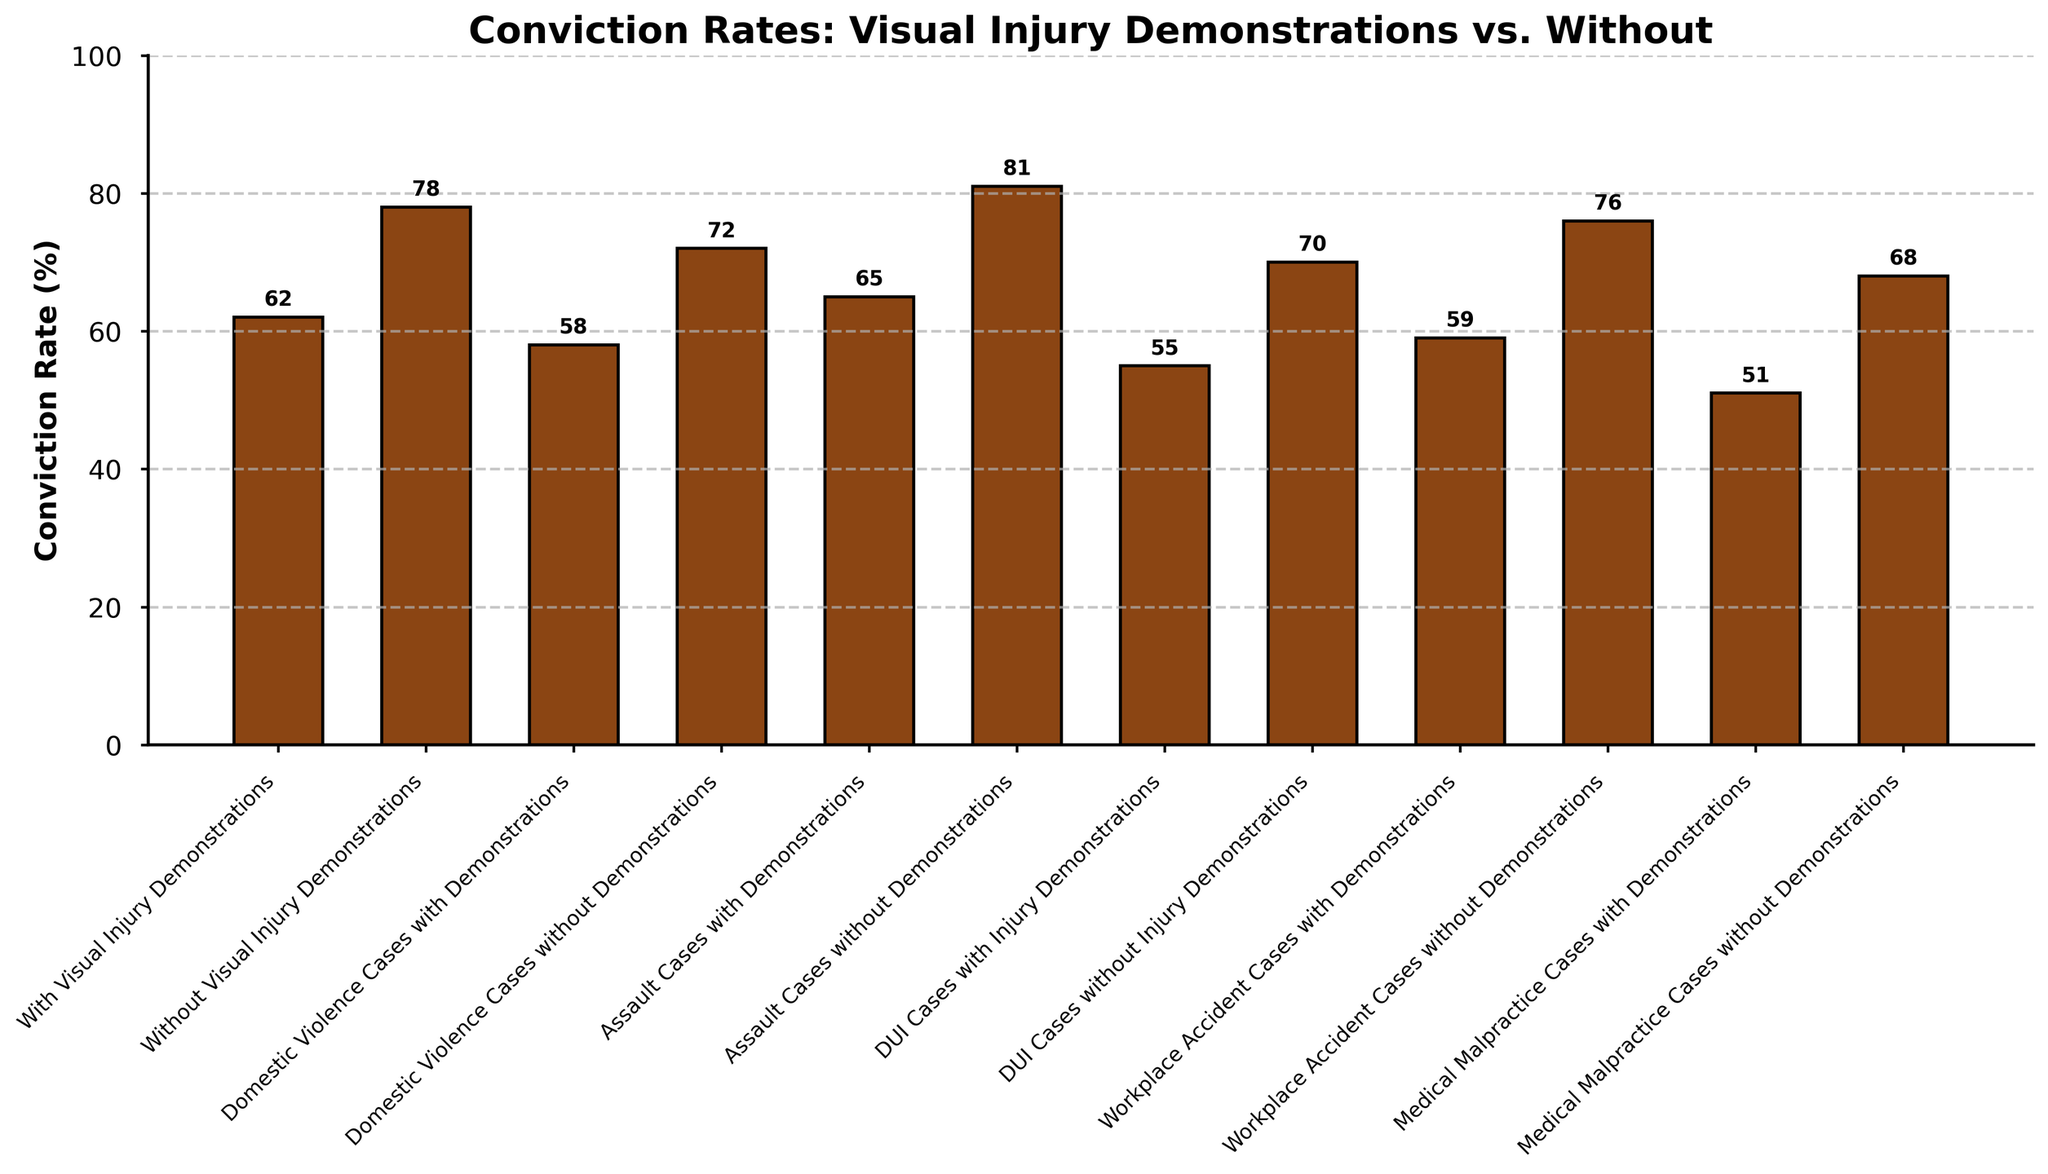Which category has the lowest conviction rate with visual injury demonstrations? The bar representing “Medical Malpractice Cases with Demonstrations” is the shortest among all bars labeled "with demonstrations," indicating the lowest rate.
Answer: Medical Malpractice Cases with Demonstrations How much higher is the conviction rate for DUI cases without visual injury demonstrations compared to those with demonstrations? The conviction rate for DUI cases without demonstrations is 70%, and with demonstrations, it is 55%. The difference can be calculated as 70% - 55% = 15%.
Answer: 15% Which case type shows the largest difference in conviction rates between using visual injury demonstrations and not using them? Calculating the difference for each case type, the differences are as follows:
- Domestic Violence Cases: 72% - 58% = 14%
- Assault Cases: 81% - 65% = 16%
- DUI Cases: 70% - 55% = 15%
- Workplace Accident Cases: 76% - 59% = 17%
- Medical Malpractice Cases: 68% - 51% = 17%
The largest differences are in Workplace Accident Cases and Medical Malpractice Cases, both 17%.
Answer: Workplace Accident Cases and Medical Malpractice Cases What is the average conviction rate for cases with visual injury demonstrations? Adding up the conviction rates for all types of cases with visual injury demonstrations and dividing it by the number of case types:
(62 + 58 + 65 + 55 + 59 + 51) / 6 = 350 / 6 = 58.33%.
Answer: 58.33% How does the conviction rate for Domestic Violence Cases without demonstrations compare to the average rate for all cases with demonstrations? The conviction rate for Domestic Violence Cases without demonstrations is 72%. The average rate for all cases with visual injury demonstrations, as calculated, is 58.33%, thus, 72% > 58.33%.
Answer: Higher What is the total span (difference) in conviction rates across all case types with visual injury demonstrations? The highest conviction rate among cases with visual demonstrations is 65% (Assault Cases), and the lowest is 51% (Medical Malpractice Cases). The total span is calculated as 65% - 51% = 14%.
Answer: 14% Which type of cases have shown a consistent trend in conviction rates irrespective of visual demonstration use (highest, lowest, etc.)? For this, we need to compare the high and low trends across cases with and without visual injury demonstrations:
- With: Highest is Assault Cases (65%), Lowest is Medical Malpractice Cases (51%)
- Without: Highest is Assault Cases (81%), Lowest is Medical Malpractice Cases (68%)
Assault and Medical Malpractice cases show consistent trends (highest and lowest, respectively) across both scenarios.
Answer: Assault and Medical Malpractice Cases 